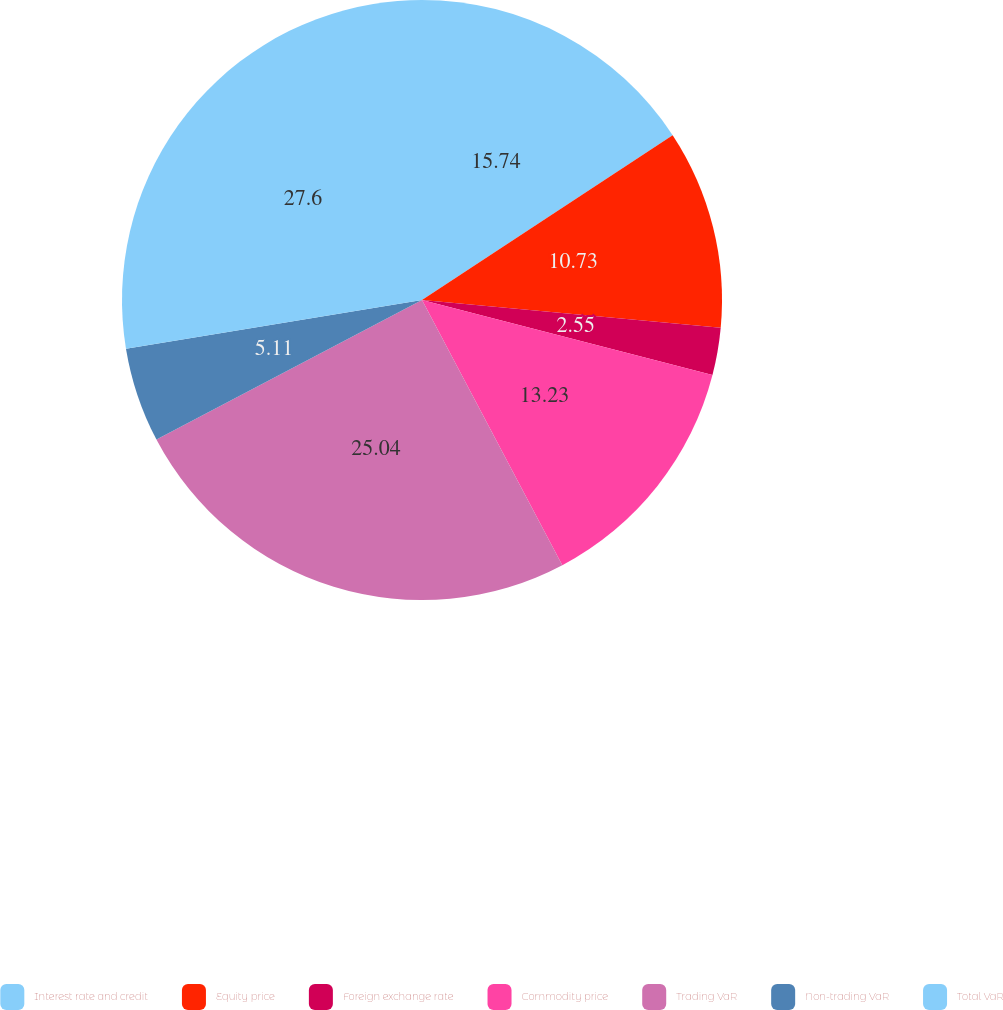Convert chart to OTSL. <chart><loc_0><loc_0><loc_500><loc_500><pie_chart><fcel>Interest rate and credit<fcel>Equity price<fcel>Foreign exchange rate<fcel>Commodity price<fcel>Trading VaR<fcel>Non-trading VaR<fcel>Total VaR<nl><fcel>15.74%<fcel>10.73%<fcel>2.55%<fcel>13.23%<fcel>25.04%<fcel>5.11%<fcel>27.59%<nl></chart> 